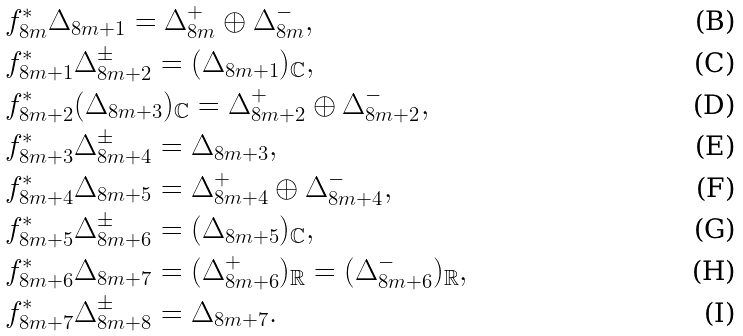<formula> <loc_0><loc_0><loc_500><loc_500>& f _ { 8 m } ^ { * } \Delta _ { 8 m + 1 } = \Delta _ { 8 m } ^ { + } \oplus \Delta _ { 8 m } ^ { - } , \\ & f _ { 8 m + 1 } ^ { * } \Delta _ { 8 m + 2 } ^ { \pm } = ( \Delta _ { 8 m + 1 } ) _ { \mathbb { C } } , \\ & f _ { 8 m + 2 } ^ { * } ( \Delta _ { 8 m + 3 } ) _ { \mathbb { C } } = \Delta _ { 8 m + 2 } ^ { + } \oplus \Delta _ { 8 m + 2 } ^ { - } , \\ & f _ { 8 m + 3 } ^ { * } \Delta _ { 8 m + 4 } ^ { \pm } = \Delta _ { 8 m + 3 } , \\ & f _ { 8 m + 4 } ^ { * } \Delta _ { 8 m + 5 } = \Delta _ { 8 m + 4 } ^ { + } \oplus \Delta _ { 8 m + 4 } ^ { - } , \\ & f _ { 8 m + 5 } ^ { * } \Delta _ { 8 m + 6 } ^ { \pm } = ( \Delta _ { 8 m + 5 } ) _ { \mathbb { C } } , \\ & f _ { 8 m + 6 } ^ { * } \Delta _ { 8 m + 7 } = ( \Delta _ { 8 m + 6 } ^ { + } ) _ { \mathbb { R } } = ( \Delta _ { 8 m + 6 } ^ { - } ) _ { \mathbb { R } } , \\ & f _ { 8 m + 7 } ^ { * } \Delta _ { 8 m + 8 } ^ { \pm } = \Delta _ { 8 m + 7 } .</formula> 